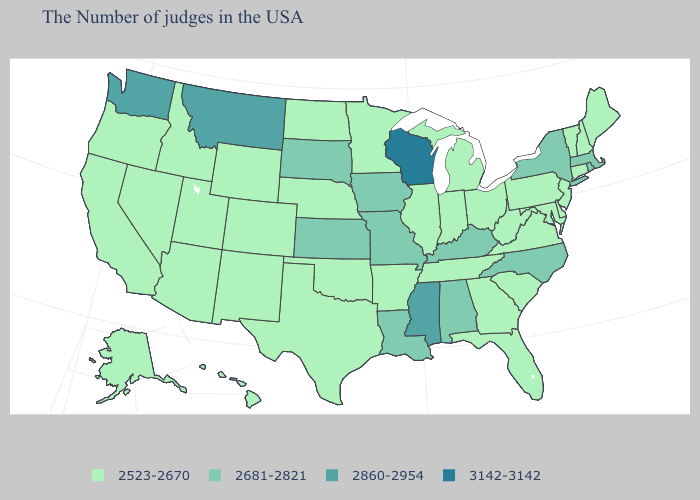Which states have the highest value in the USA?
Keep it brief. Wisconsin. Which states have the lowest value in the Northeast?
Give a very brief answer. Maine, New Hampshire, Vermont, Connecticut, New Jersey, Pennsylvania. Does Alaska have the same value as Wisconsin?
Write a very short answer. No. What is the value of Texas?
Keep it brief. 2523-2670. Which states have the lowest value in the West?
Answer briefly. Wyoming, Colorado, New Mexico, Utah, Arizona, Idaho, Nevada, California, Oregon, Alaska, Hawaii. Name the states that have a value in the range 2523-2670?
Concise answer only. Maine, New Hampshire, Vermont, Connecticut, New Jersey, Delaware, Maryland, Pennsylvania, Virginia, South Carolina, West Virginia, Ohio, Florida, Georgia, Michigan, Indiana, Tennessee, Illinois, Arkansas, Minnesota, Nebraska, Oklahoma, Texas, North Dakota, Wyoming, Colorado, New Mexico, Utah, Arizona, Idaho, Nevada, California, Oregon, Alaska, Hawaii. Does Alabama have a higher value than New Jersey?
Keep it brief. Yes. Does Washington have the same value as Montana?
Be succinct. Yes. What is the value of Texas?
Keep it brief. 2523-2670. How many symbols are there in the legend?
Quick response, please. 4. Does Delaware have a lower value than New York?
Keep it brief. Yes. Which states hav the highest value in the MidWest?
Give a very brief answer. Wisconsin. Which states have the lowest value in the Northeast?
Be succinct. Maine, New Hampshire, Vermont, Connecticut, New Jersey, Pennsylvania. Name the states that have a value in the range 3142-3142?
Quick response, please. Wisconsin. Name the states that have a value in the range 2681-2821?
Be succinct. Massachusetts, Rhode Island, New York, North Carolina, Kentucky, Alabama, Louisiana, Missouri, Iowa, Kansas, South Dakota. 